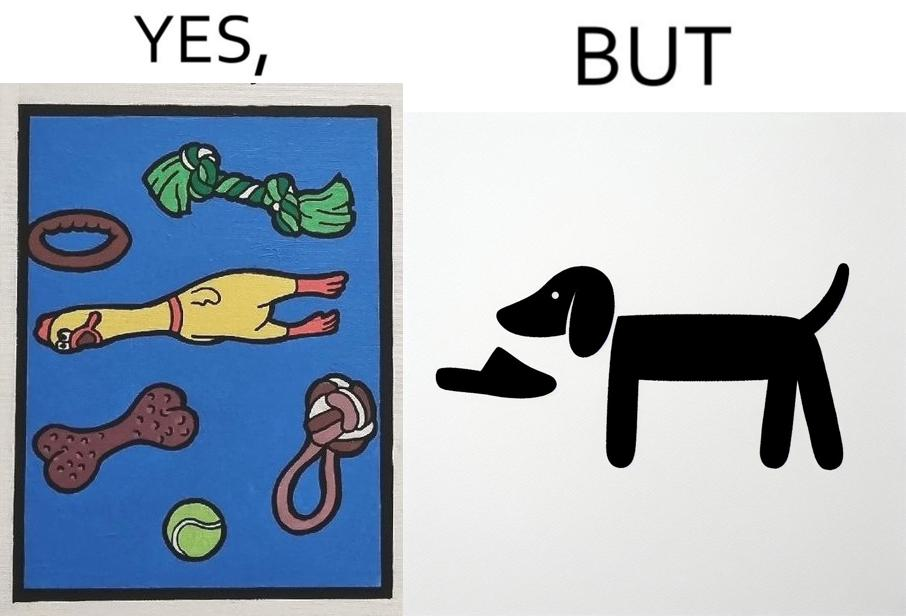Explain the humor or irony in this image. the irony is that dog owners buy loads of toys for their dog but the dog's favourite toy is the owner's slippers 